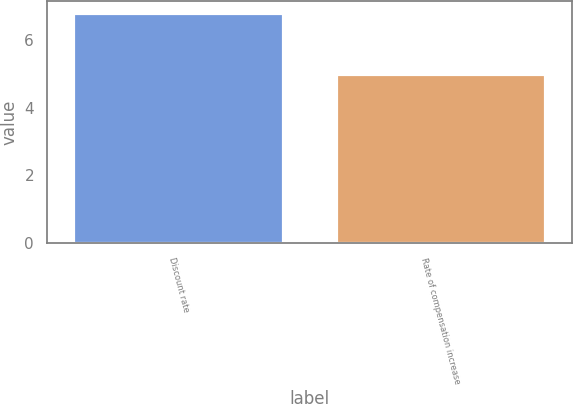Convert chart to OTSL. <chart><loc_0><loc_0><loc_500><loc_500><bar_chart><fcel>Discount rate<fcel>Rate of compensation increase<nl><fcel>6.8<fcel>5<nl></chart> 